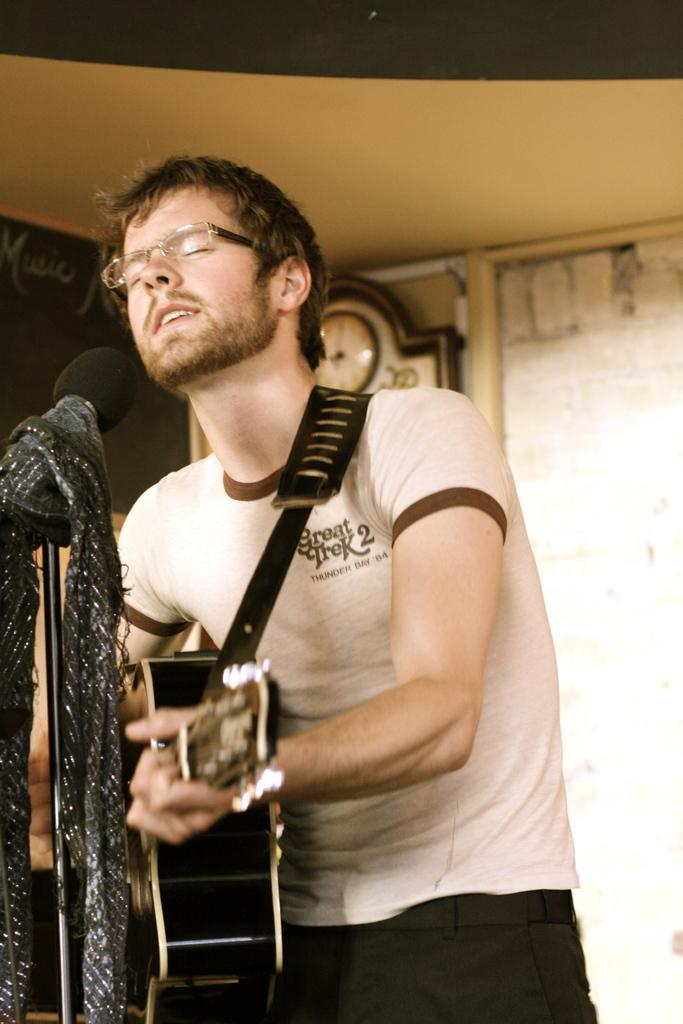What is the person in the image doing? The person is playing a guitar. What object is present in the image that is commonly used for amplifying sound? There is a microphone in the image. What can be seen in the background of the image? There is a clock and a wall in the background of the image. What type of destruction can be seen happening to the stove in the image? There is no stove present in the image, and therefore no destruction can be observed. 